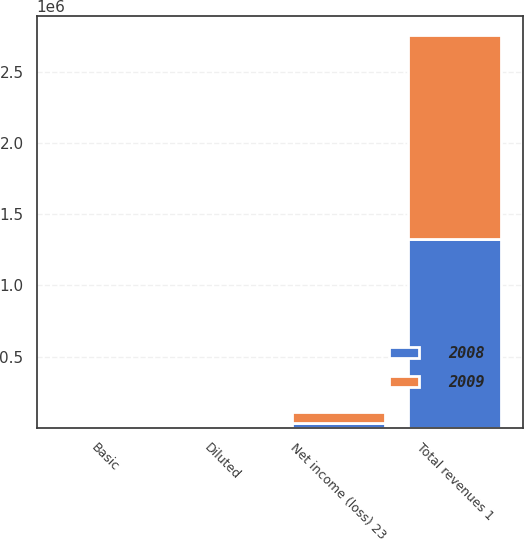Convert chart. <chart><loc_0><loc_0><loc_500><loc_500><stacked_bar_chart><ecel><fcel>Total revenues 1<fcel>Net income (loss) 23<fcel>Basic<fcel>Diluted<nl><fcel>2008<fcel>1.3256e+06<fcel>36238<fcel>0.17<fcel>0.17<nl><fcel>2009<fcel>1.42908e+06<fcel>75607<fcel>0.35<fcel>0.35<nl></chart> 